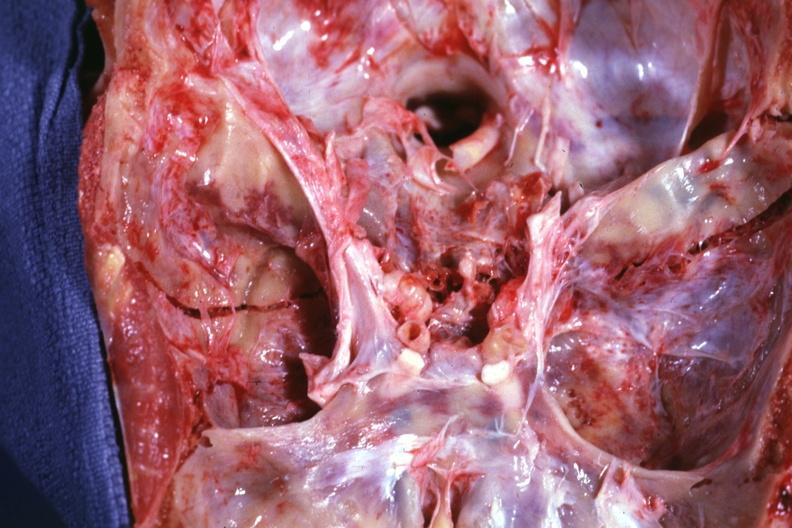s bone, calvarium present?
Answer the question using a single word or phrase. Yes 